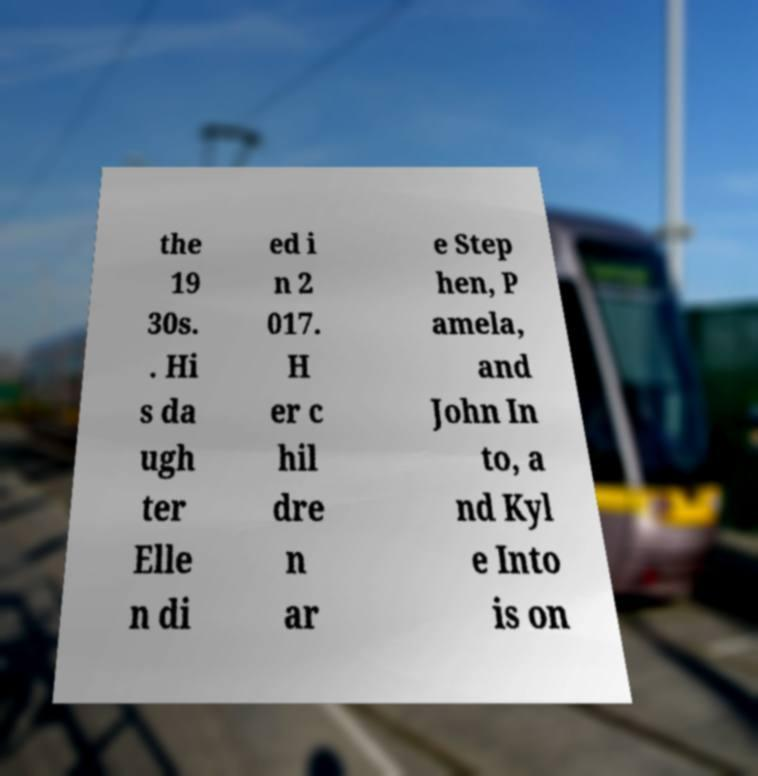Can you read and provide the text displayed in the image?This photo seems to have some interesting text. Can you extract and type it out for me? the 19 30s. . Hi s da ugh ter Elle n di ed i n 2 017. H er c hil dre n ar e Step hen, P amela, and John In to, a nd Kyl e Into is on 